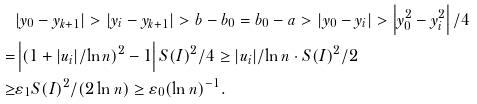<formula> <loc_0><loc_0><loc_500><loc_500>& | y _ { 0 } - y _ { k + 1 } | > | y _ { i } - y _ { k + 1 } | > b - b _ { 0 } = b _ { 0 } - a > | y _ { 0 } - y _ { i } | > \left | y _ { 0 } ^ { 2 } - y _ { i } ^ { 2 } \right | / 4 \\ = & \left | ( 1 + | u _ { i } | / \ln n ) ^ { 2 } - 1 \right | S ( I ) ^ { 2 } / 4 \geq | u _ { i } | / \ln n \cdot S ( I ) ^ { 2 } / 2 \\ \geq & \varepsilon _ { 1 } S ( I ) ^ { 2 } / ( 2 \ln n ) \geq \varepsilon _ { 0 } ( \ln n ) ^ { - 1 } .</formula> 